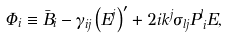<formula> <loc_0><loc_0><loc_500><loc_500>\Phi _ { i } \equiv \bar { B } _ { i } - \gamma _ { i j } \left ( E ^ { j } \right ) ^ { \prime } + 2 i k ^ { j } \sigma _ { l j } P ^ { l } _ { \, i } E ,</formula> 